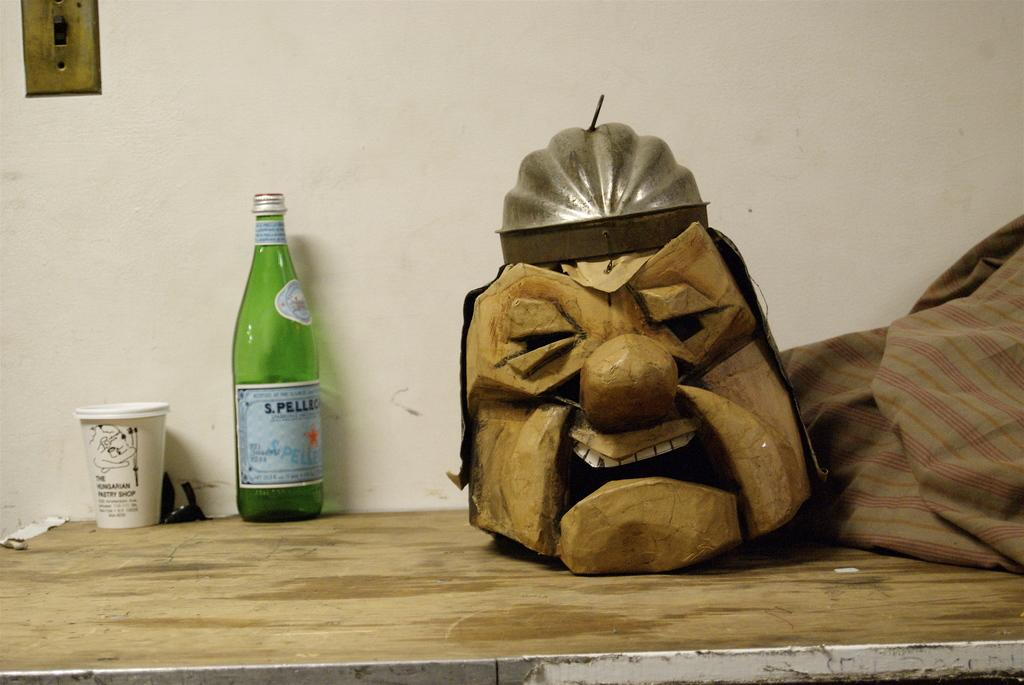Where was the image taken? The image was taken in a room. What furniture is present in the room? There is a table in the room. What object is placed on the table? A green bottle is placed on the table. What other items can be seen on the table? Caps, a cloth, and a wooden carving are present on the table. What color is the wall visible in the image? The wall visible in the image is white. How many kittens are playing on the table in the image? There are no kittens present in the image; the table contains a green bottle, caps, a cloth, and a wooden carving. 